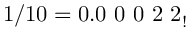Convert formula to latex. <formula><loc_0><loc_0><loc_500><loc_500>1 / 1 0 = 0 . 0 \ 0 \ 0 \ 2 \ 2 _ { ! }</formula> 